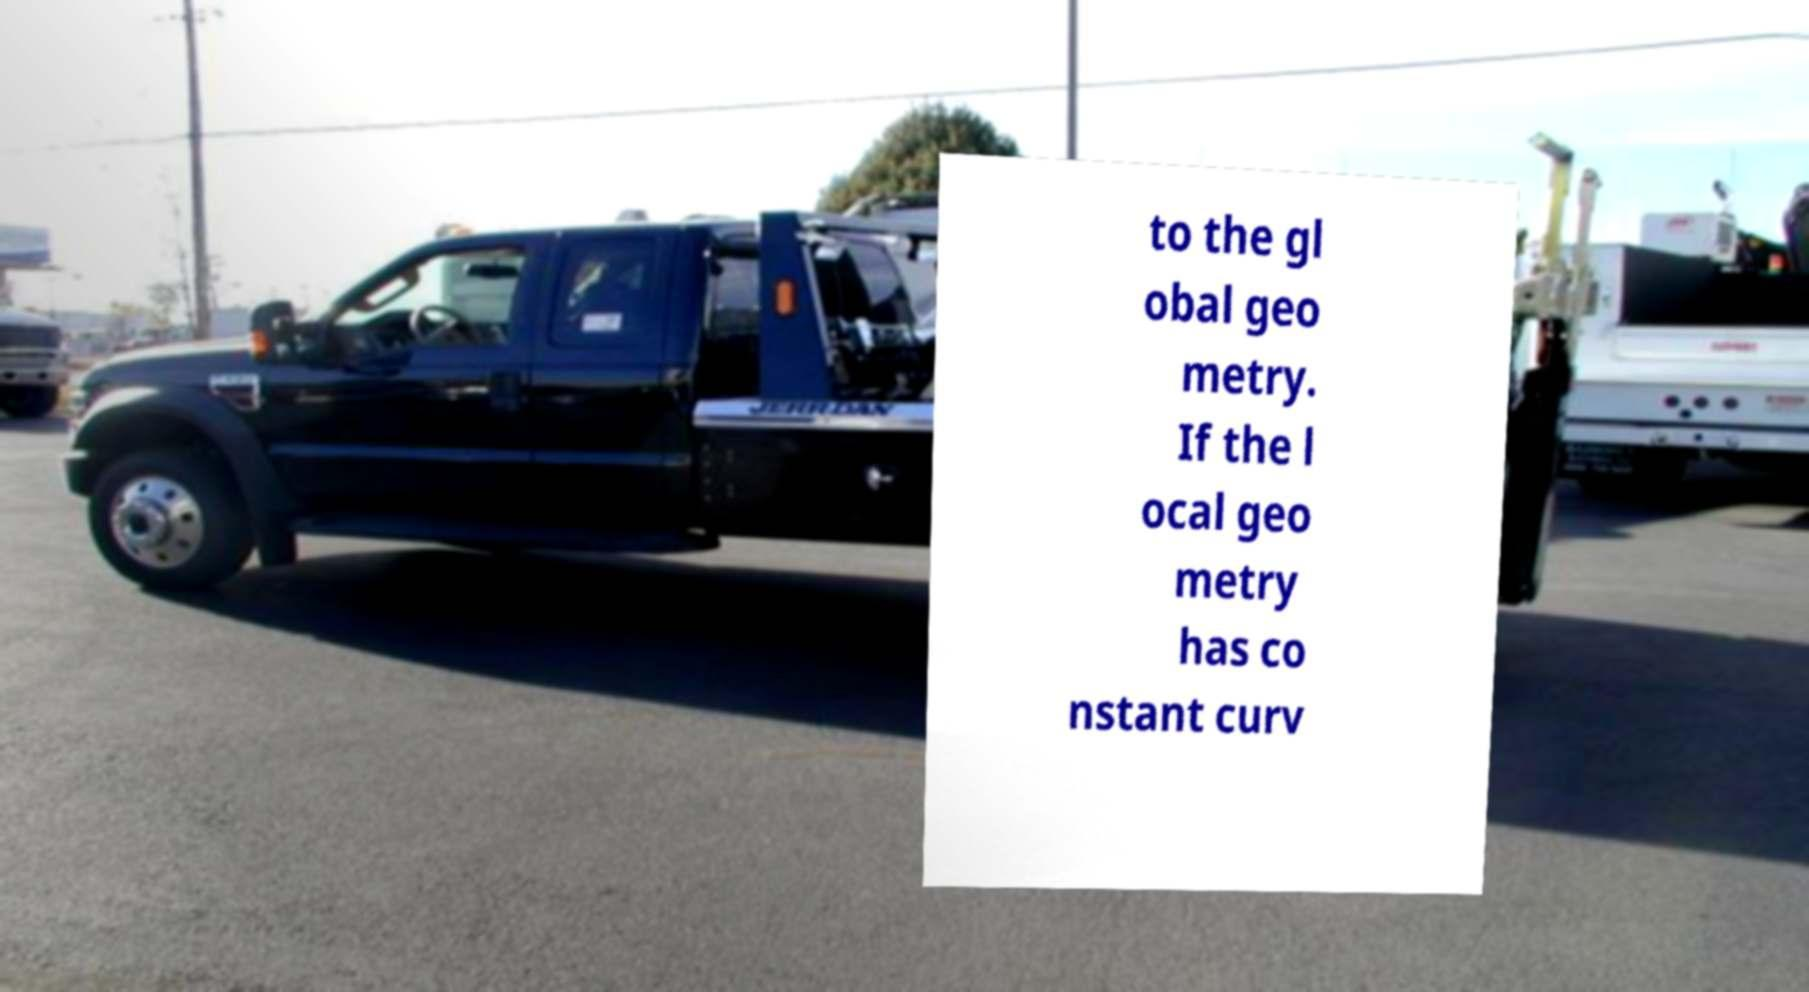Please identify and transcribe the text found in this image. to the gl obal geo metry. If the l ocal geo metry has co nstant curv 